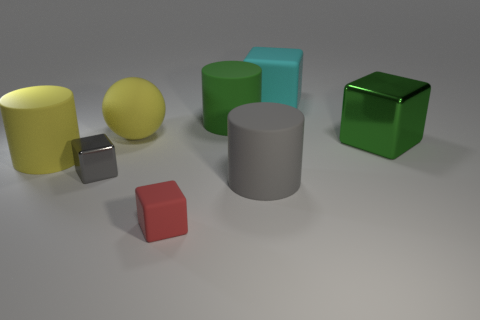Subtract 1 cubes. How many cubes are left? 3 Add 2 green rubber objects. How many objects exist? 10 Subtract all gray cubes. How many cubes are left? 3 Subtract all red rubber cubes. How many cubes are left? 3 Subtract all cylinders. How many objects are left? 5 Subtract all blue blocks. Subtract all red cylinders. How many blocks are left? 4 Subtract all large blue objects. Subtract all cyan matte cubes. How many objects are left? 7 Add 4 big spheres. How many big spheres are left? 5 Add 5 tiny green blocks. How many tiny green blocks exist? 5 Subtract 0 brown balls. How many objects are left? 8 